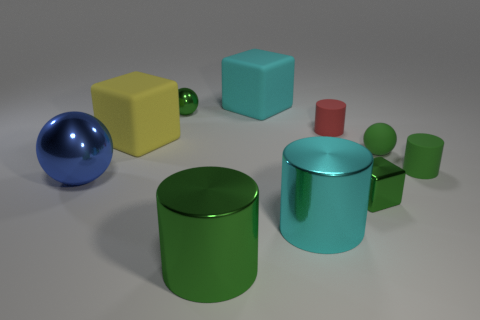What material is the tiny object that is the same shape as the large yellow rubber object?
Provide a succinct answer. Metal. What is the shape of the blue shiny object?
Provide a short and direct response. Sphere. What material is the green thing that is both to the right of the big cyan rubber block and in front of the large blue shiny ball?
Your answer should be very brief. Metal. There is a big blue object that is made of the same material as the big green object; what shape is it?
Your response must be concise. Sphere. There is a green sphere that is the same material as the big green object; what is its size?
Provide a succinct answer. Small. The big object that is both behind the green rubber cylinder and in front of the large cyan rubber cube has what shape?
Ensure brevity in your answer.  Cube. What is the size of the cylinder that is behind the tiny ball that is on the right side of the cyan block?
Offer a very short reply. Small. What number of other objects are there of the same color as the large sphere?
Give a very brief answer. 0. What material is the blue ball?
Ensure brevity in your answer.  Metal. Are there any small yellow cubes?
Keep it short and to the point. No. 